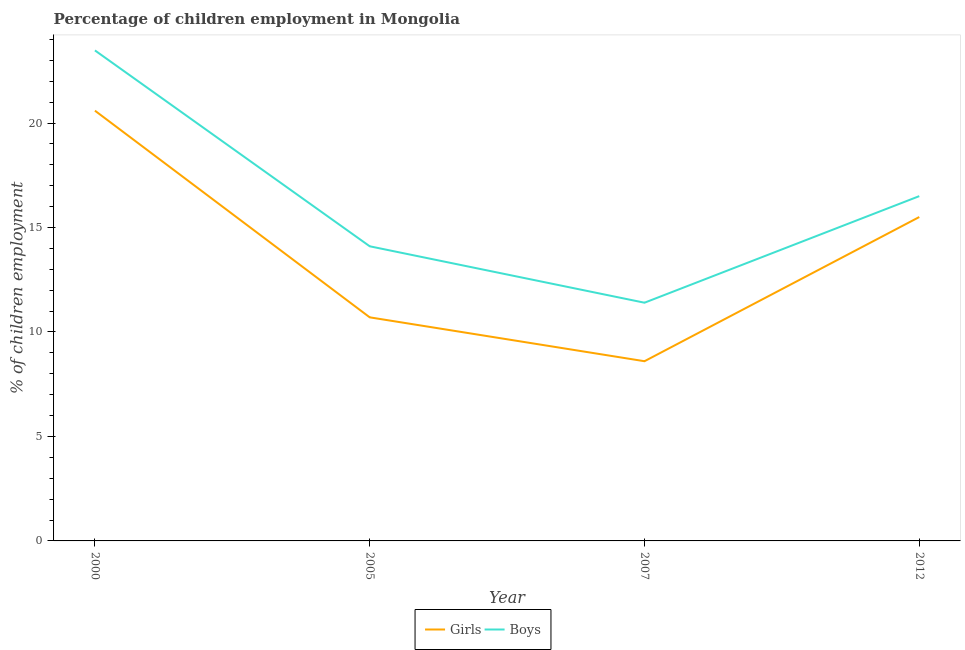Does the line corresponding to percentage of employed girls intersect with the line corresponding to percentage of employed boys?
Keep it short and to the point. No. Is the number of lines equal to the number of legend labels?
Make the answer very short. Yes. What is the percentage of employed boys in 2012?
Your answer should be very brief. 16.5. Across all years, what is the maximum percentage of employed boys?
Provide a short and direct response. 23.47. Across all years, what is the minimum percentage of employed girls?
Your response must be concise. 8.6. In which year was the percentage of employed boys minimum?
Make the answer very short. 2007. What is the total percentage of employed girls in the graph?
Your answer should be compact. 55.39. What is the difference between the percentage of employed boys in 2000 and that in 2012?
Your response must be concise. 6.97. What is the difference between the percentage of employed girls in 2005 and the percentage of employed boys in 2000?
Provide a succinct answer. -12.77. What is the average percentage of employed boys per year?
Your answer should be very brief. 16.37. In the year 2000, what is the difference between the percentage of employed boys and percentage of employed girls?
Offer a very short reply. 2.88. In how many years, is the percentage of employed boys greater than 20 %?
Provide a succinct answer. 1. What is the ratio of the percentage of employed girls in 2000 to that in 2012?
Keep it short and to the point. 1.33. Is the difference between the percentage of employed girls in 2005 and 2007 greater than the difference between the percentage of employed boys in 2005 and 2007?
Offer a very short reply. No. What is the difference between the highest and the second highest percentage of employed girls?
Provide a succinct answer. 5.09. What is the difference between the highest and the lowest percentage of employed girls?
Ensure brevity in your answer.  11.99. Does the percentage of employed boys monotonically increase over the years?
Your answer should be very brief. No. Is the percentage of employed boys strictly greater than the percentage of employed girls over the years?
Provide a short and direct response. Yes. Is the percentage of employed girls strictly less than the percentage of employed boys over the years?
Keep it short and to the point. Yes. Are the values on the major ticks of Y-axis written in scientific E-notation?
Provide a short and direct response. No. Where does the legend appear in the graph?
Keep it short and to the point. Bottom center. What is the title of the graph?
Provide a short and direct response. Percentage of children employment in Mongolia. What is the label or title of the Y-axis?
Your answer should be compact. % of children employment. What is the % of children employment of Girls in 2000?
Give a very brief answer. 20.59. What is the % of children employment in Boys in 2000?
Make the answer very short. 23.47. What is the % of children employment in Boys in 2012?
Provide a succinct answer. 16.5. Across all years, what is the maximum % of children employment of Girls?
Provide a short and direct response. 20.59. Across all years, what is the maximum % of children employment in Boys?
Your answer should be compact. 23.47. Across all years, what is the minimum % of children employment in Girls?
Give a very brief answer. 8.6. What is the total % of children employment of Girls in the graph?
Your answer should be very brief. 55.39. What is the total % of children employment in Boys in the graph?
Provide a short and direct response. 65.47. What is the difference between the % of children employment of Girls in 2000 and that in 2005?
Your answer should be very brief. 9.89. What is the difference between the % of children employment of Boys in 2000 and that in 2005?
Provide a succinct answer. 9.37. What is the difference between the % of children employment in Girls in 2000 and that in 2007?
Offer a terse response. 11.99. What is the difference between the % of children employment in Boys in 2000 and that in 2007?
Offer a terse response. 12.07. What is the difference between the % of children employment in Girls in 2000 and that in 2012?
Your answer should be very brief. 5.09. What is the difference between the % of children employment of Boys in 2000 and that in 2012?
Your response must be concise. 6.97. What is the difference between the % of children employment in Girls in 2005 and that in 2007?
Offer a very short reply. 2.1. What is the difference between the % of children employment in Boys in 2005 and that in 2012?
Ensure brevity in your answer.  -2.4. What is the difference between the % of children employment in Girls in 2007 and that in 2012?
Make the answer very short. -6.9. What is the difference between the % of children employment in Boys in 2007 and that in 2012?
Your response must be concise. -5.1. What is the difference between the % of children employment in Girls in 2000 and the % of children employment in Boys in 2005?
Provide a succinct answer. 6.49. What is the difference between the % of children employment in Girls in 2000 and the % of children employment in Boys in 2007?
Provide a succinct answer. 9.19. What is the difference between the % of children employment in Girls in 2000 and the % of children employment in Boys in 2012?
Offer a very short reply. 4.09. What is the difference between the % of children employment in Girls in 2005 and the % of children employment in Boys in 2007?
Your response must be concise. -0.7. What is the difference between the % of children employment of Girls in 2005 and the % of children employment of Boys in 2012?
Provide a succinct answer. -5.8. What is the difference between the % of children employment of Girls in 2007 and the % of children employment of Boys in 2012?
Your response must be concise. -7.9. What is the average % of children employment in Girls per year?
Your answer should be compact. 13.85. What is the average % of children employment of Boys per year?
Ensure brevity in your answer.  16.37. In the year 2000, what is the difference between the % of children employment of Girls and % of children employment of Boys?
Your answer should be very brief. -2.88. In the year 2012, what is the difference between the % of children employment in Girls and % of children employment in Boys?
Give a very brief answer. -1. What is the ratio of the % of children employment in Girls in 2000 to that in 2005?
Give a very brief answer. 1.92. What is the ratio of the % of children employment of Boys in 2000 to that in 2005?
Offer a very short reply. 1.66. What is the ratio of the % of children employment of Girls in 2000 to that in 2007?
Your response must be concise. 2.39. What is the ratio of the % of children employment of Boys in 2000 to that in 2007?
Your answer should be compact. 2.06. What is the ratio of the % of children employment in Girls in 2000 to that in 2012?
Offer a terse response. 1.33. What is the ratio of the % of children employment in Boys in 2000 to that in 2012?
Ensure brevity in your answer.  1.42. What is the ratio of the % of children employment in Girls in 2005 to that in 2007?
Keep it short and to the point. 1.24. What is the ratio of the % of children employment of Boys in 2005 to that in 2007?
Offer a terse response. 1.24. What is the ratio of the % of children employment of Girls in 2005 to that in 2012?
Provide a succinct answer. 0.69. What is the ratio of the % of children employment of Boys in 2005 to that in 2012?
Offer a terse response. 0.85. What is the ratio of the % of children employment of Girls in 2007 to that in 2012?
Your answer should be very brief. 0.55. What is the ratio of the % of children employment in Boys in 2007 to that in 2012?
Provide a succinct answer. 0.69. What is the difference between the highest and the second highest % of children employment of Girls?
Provide a short and direct response. 5.09. What is the difference between the highest and the second highest % of children employment in Boys?
Provide a short and direct response. 6.97. What is the difference between the highest and the lowest % of children employment of Girls?
Make the answer very short. 11.99. What is the difference between the highest and the lowest % of children employment in Boys?
Provide a short and direct response. 12.07. 